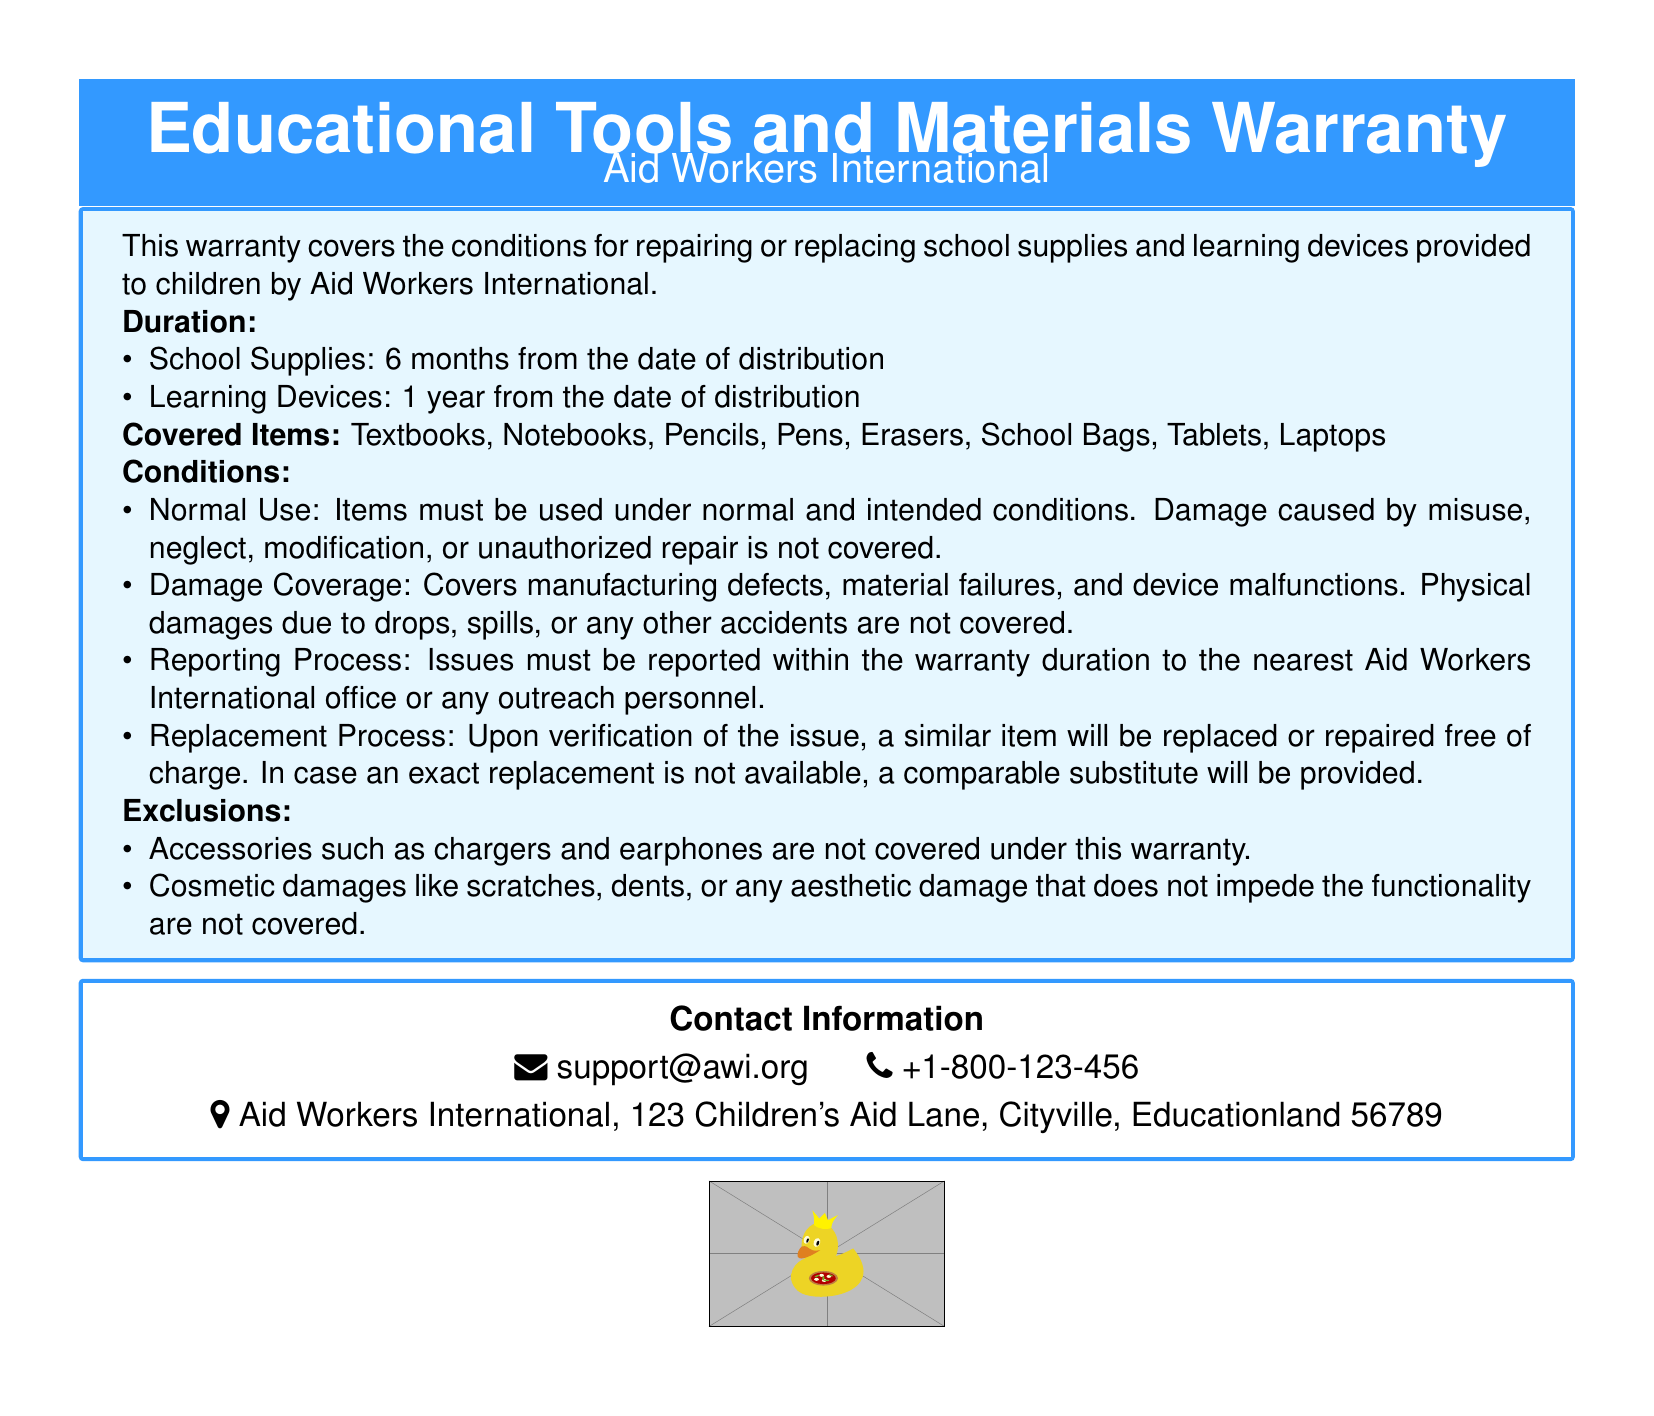What is the duration for school supplies? The document states that school supplies are covered for 6 months from the date of distribution.
Answer: 6 months What is covered under the warranty? The warranty covers items such as textbooks, notebooks, pencils, pens, erasers, school bags, tablets, and laptops.
Answer: Textbooks, Notebooks, Pencils, Pens, Erasers, School Bags, Tablets, Laptops How long are learning devices covered? The warranty specifies that learning devices are covered for 1 year from the date of distribution.
Answer: 1 year What must be reported within the warranty duration? Issues related to school supplies and learning devices must be reported within the warranty duration.
Answer: Issues What is not covered under this warranty? Cosmetic damages like scratches and dents that do not affect functionality are not covered.
Answer: Cosmetic damages Which accessories are excluded from the warranty? Accessories such as chargers and earphones are specifically excluded under this warranty.
Answer: Chargers and earphones What happens if an exact replacement is not available? If an exact replacement is not available, a comparable substitute will be provided.
Answer: Comparable substitute Where can support be contacted? Contact information for support is provided as an email and phone number.
Answer: support@awi.org and +1-800-123-456 